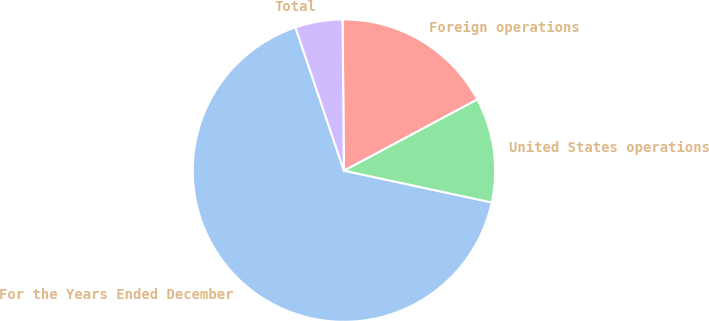Convert chart to OTSL. <chart><loc_0><loc_0><loc_500><loc_500><pie_chart><fcel>For the Years Ended December<fcel>United States operations<fcel>Foreign operations<fcel>Total<nl><fcel>66.43%<fcel>11.19%<fcel>17.33%<fcel>5.05%<nl></chart> 